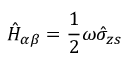Convert formula to latex. <formula><loc_0><loc_0><loc_500><loc_500>\hat { H } _ { \alpha \beta } = \frac { 1 } { 2 } \omega \hat { \sigma } _ { z s }</formula> 